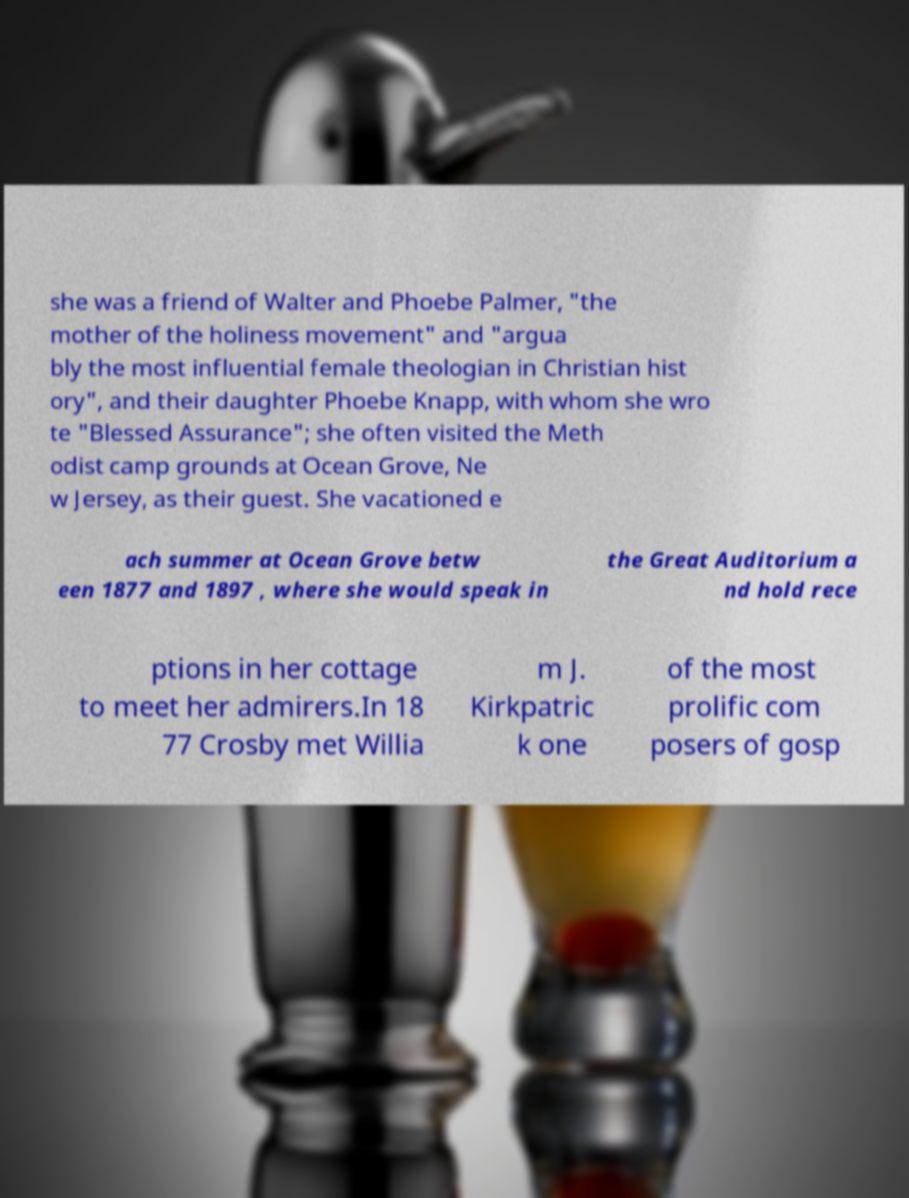Please identify and transcribe the text found in this image. she was a friend of Walter and Phoebe Palmer, "the mother of the holiness movement" and "argua bly the most influential female theologian in Christian hist ory", and their daughter Phoebe Knapp, with whom she wro te "Blessed Assurance"; she often visited the Meth odist camp grounds at Ocean Grove, Ne w Jersey, as their guest. She vacationed e ach summer at Ocean Grove betw een 1877 and 1897 , where she would speak in the Great Auditorium a nd hold rece ptions in her cottage to meet her admirers.In 18 77 Crosby met Willia m J. Kirkpatric k one of the most prolific com posers of gosp 